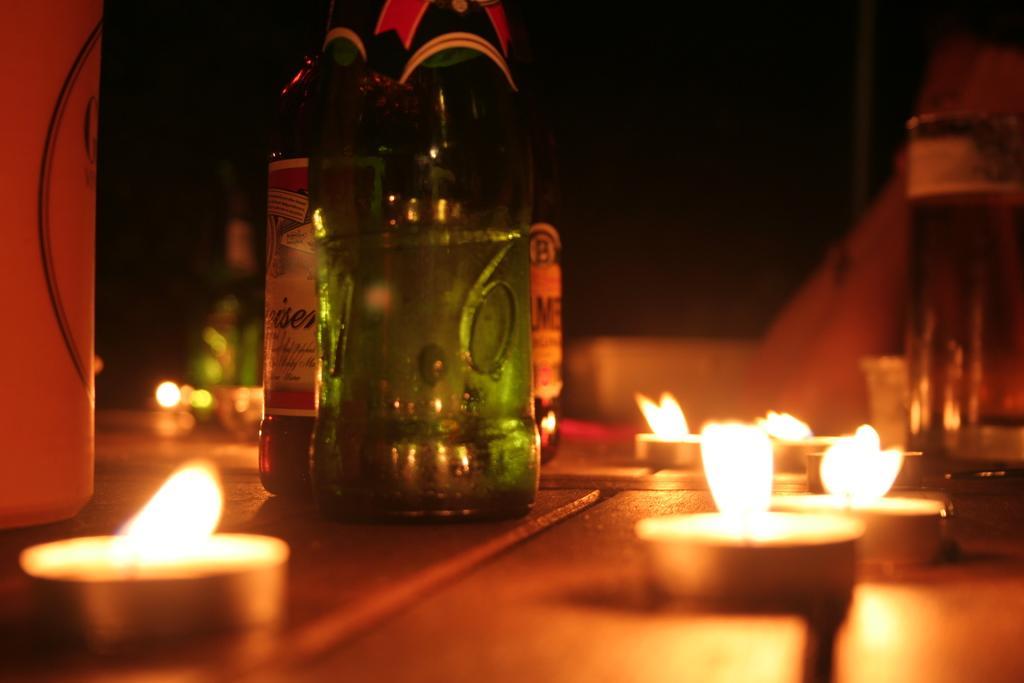In one or two sentences, can you explain what this image depicts? In this picture I can see tea lights and bottles on the path, and there is blur background. 